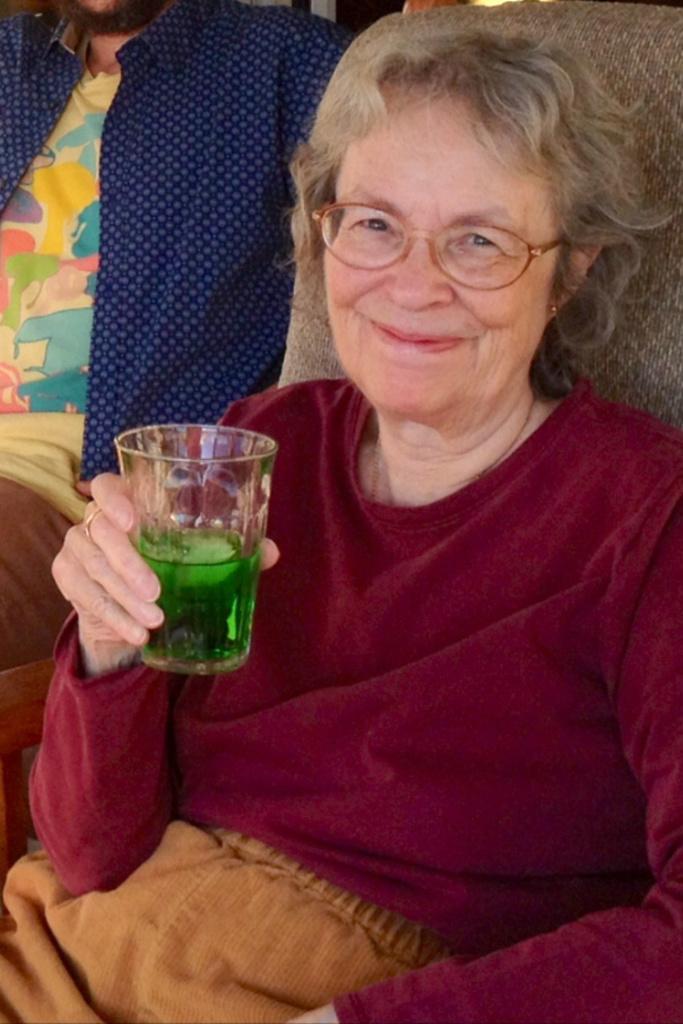Describe this image in one or two sentences. In the center of the image there is a lady holding a glass in her hand. Besides her there is a man wearing a blue color shirt. 